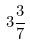<formula> <loc_0><loc_0><loc_500><loc_500>3 \frac { 3 } { 7 }</formula> 